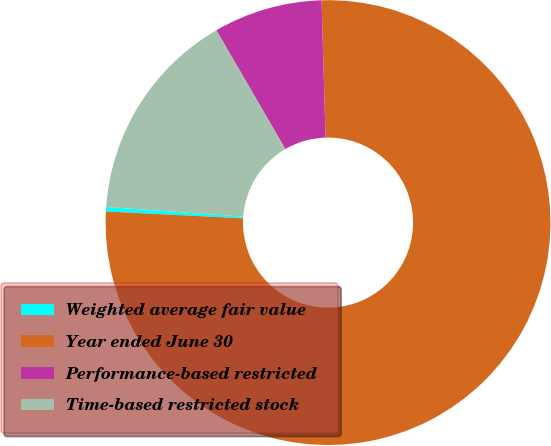<chart> <loc_0><loc_0><loc_500><loc_500><pie_chart><fcel>Weighted average fair value<fcel>Year ended June 30<fcel>Performance-based restricted<fcel>Time-based restricted stock<nl><fcel>0.32%<fcel>76.26%<fcel>7.91%<fcel>15.51%<nl></chart> 